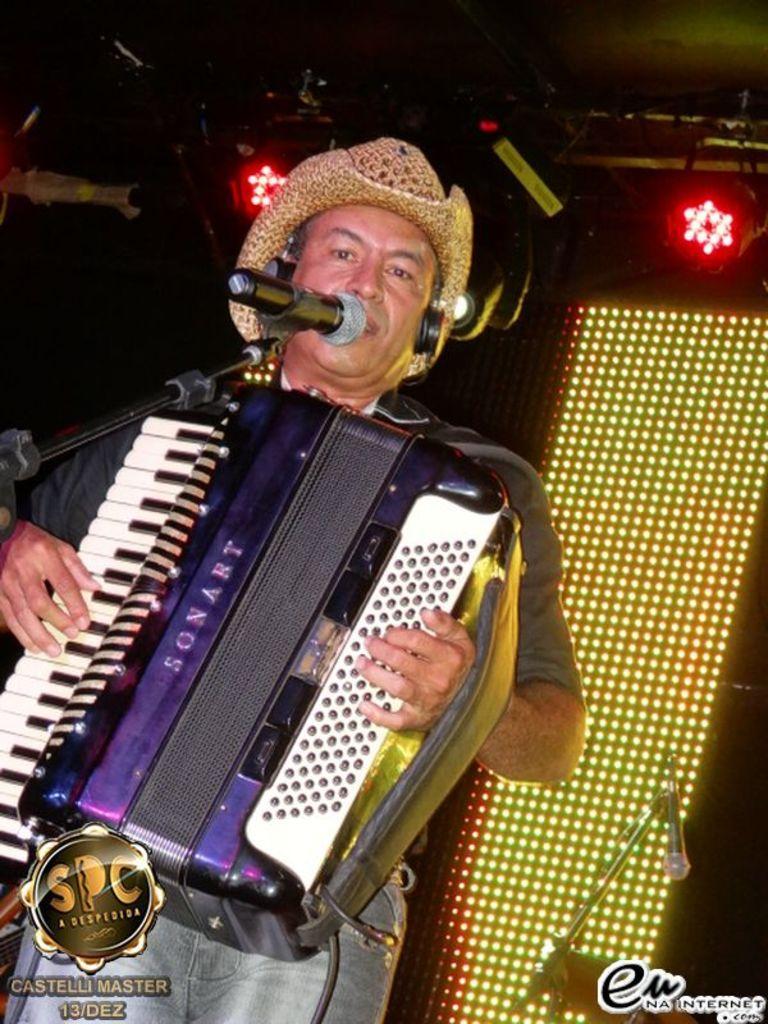Could you give a brief overview of what you see in this image? In this image we can see a person wearing hat and headphones. He is playing a musical instrument. In front of him there is a mic with mic stand. In the back there are lights. Also there is a mic with mic stand. At the bottom there is text and logos. 